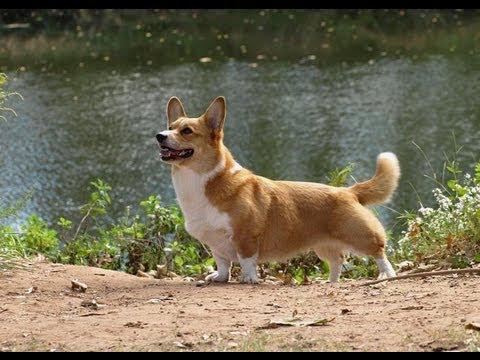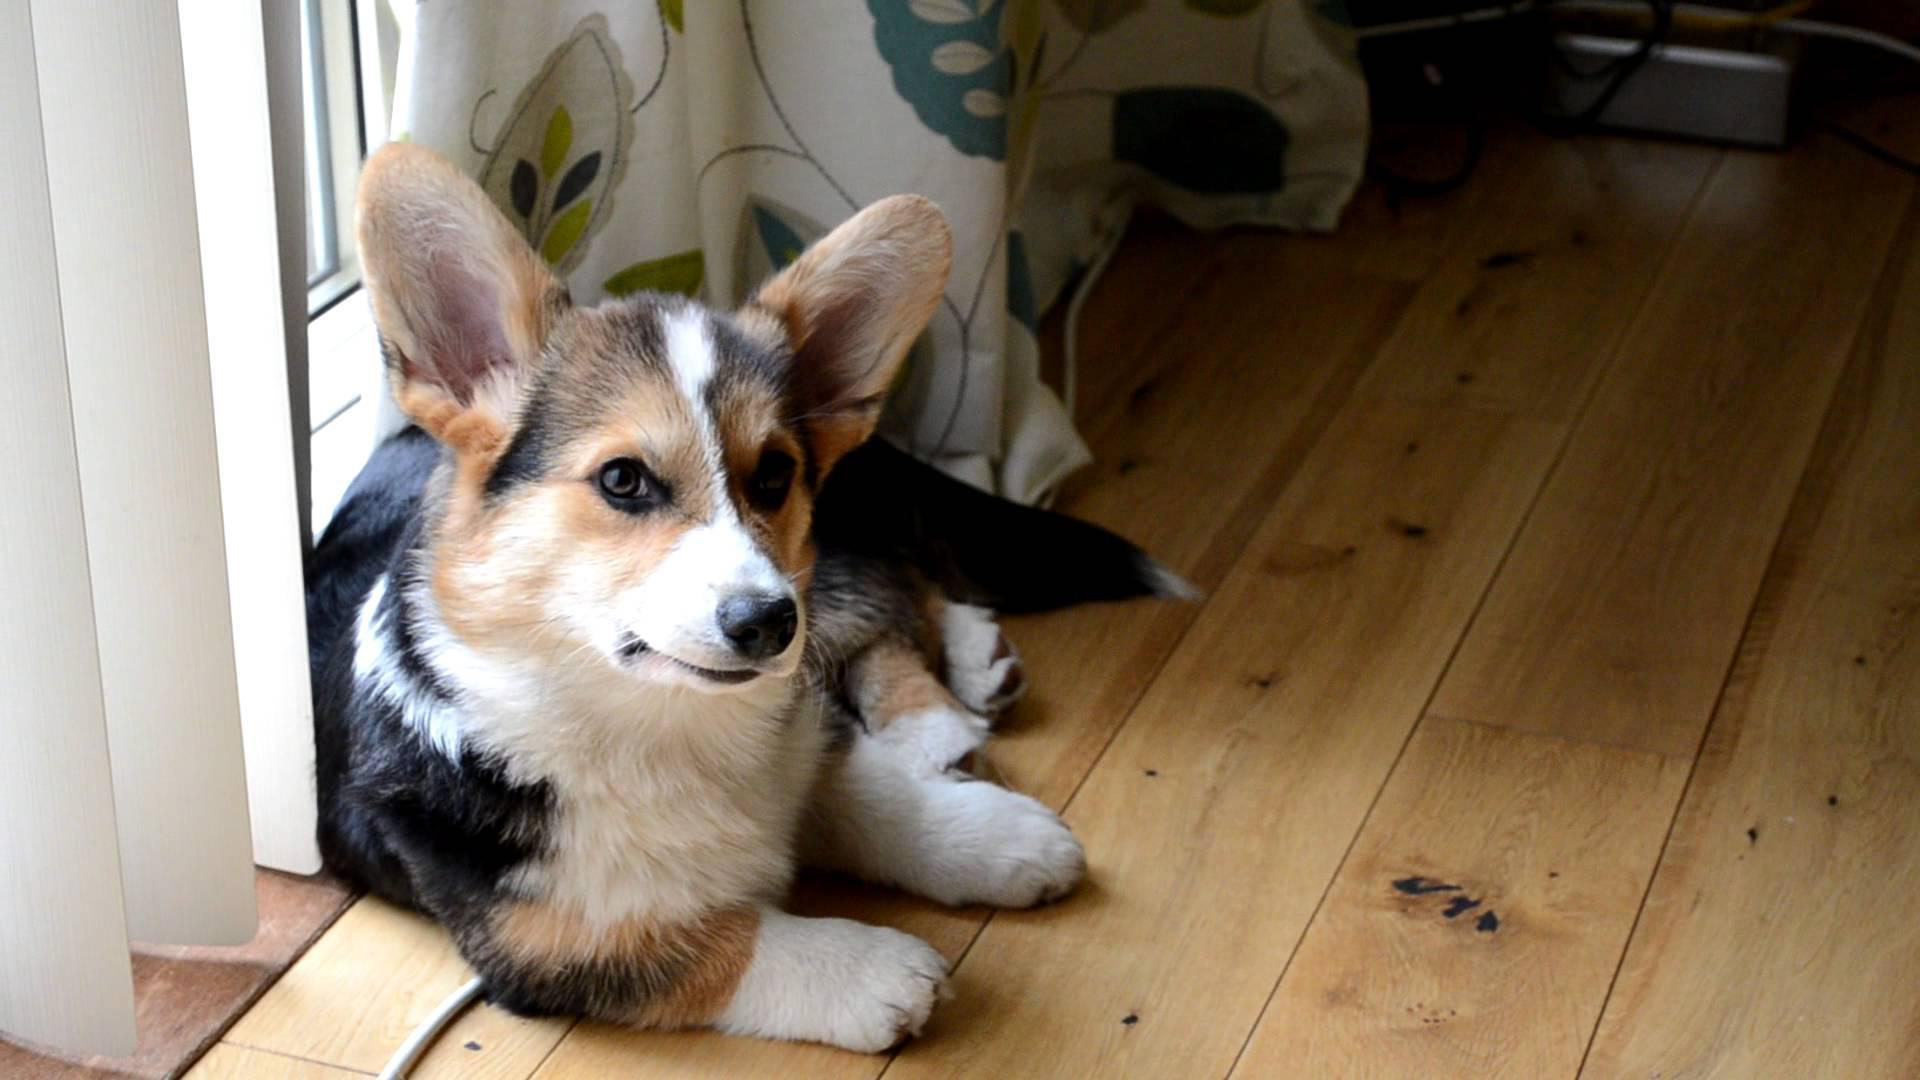The first image is the image on the left, the second image is the image on the right. For the images displayed, is the sentence "The dog in the image on the left is standing in the grass." factually correct? Answer yes or no. No. The first image is the image on the left, the second image is the image on the right. Given the left and right images, does the statement "Each image contains exactly one orange-and-white corgi, and at least one of the dogs pictured stands on all fours on green grass." hold true? Answer yes or no. No. 